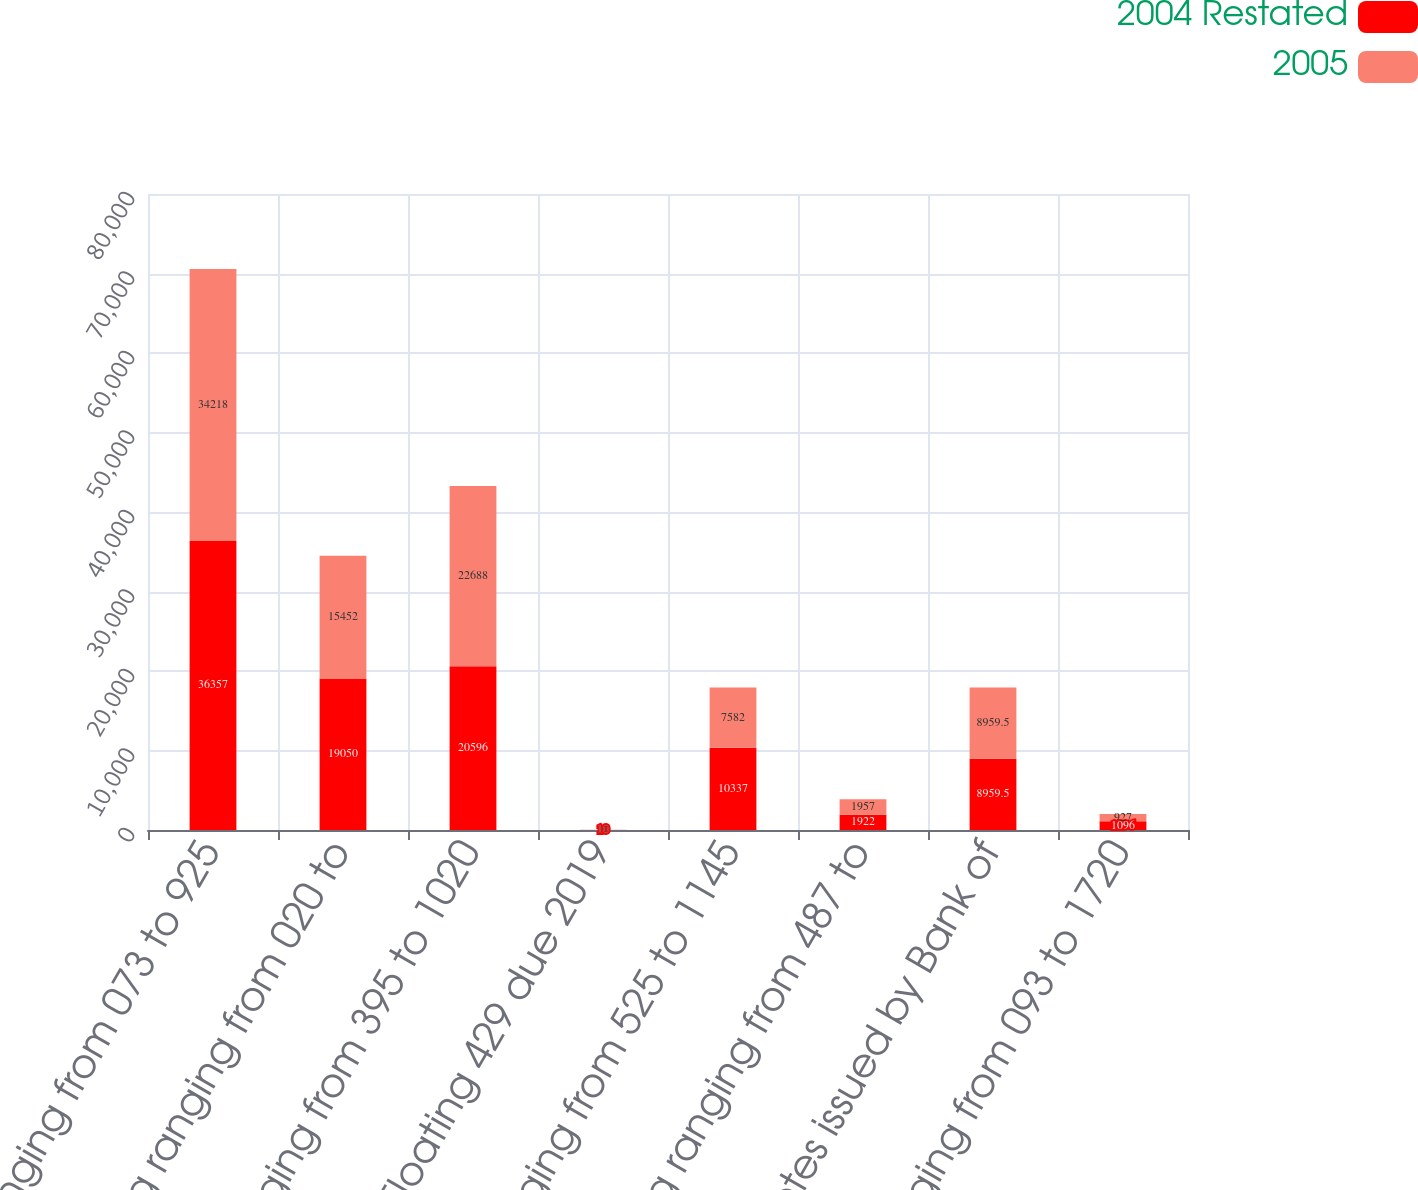Convert chart to OTSL. <chart><loc_0><loc_0><loc_500><loc_500><stacked_bar_chart><ecel><fcel>Fixed ranging from 073 to 925<fcel>Floating ranging from 020 to<fcel>Fixed ranging from 395 to 1020<fcel>Floating 429 due 2019<fcel>Fixed ranging from 525 to 1145<fcel>Floating ranging from 487 to<fcel>Total notes issued by Bank of<fcel>Fixed ranging from 093 to 1720<nl><fcel>2004 Restated<fcel>36357<fcel>19050<fcel>20596<fcel>10<fcel>10337<fcel>1922<fcel>8959.5<fcel>1096<nl><fcel>2005<fcel>34218<fcel>15452<fcel>22688<fcel>10<fcel>7582<fcel>1957<fcel>8959.5<fcel>927<nl></chart> 